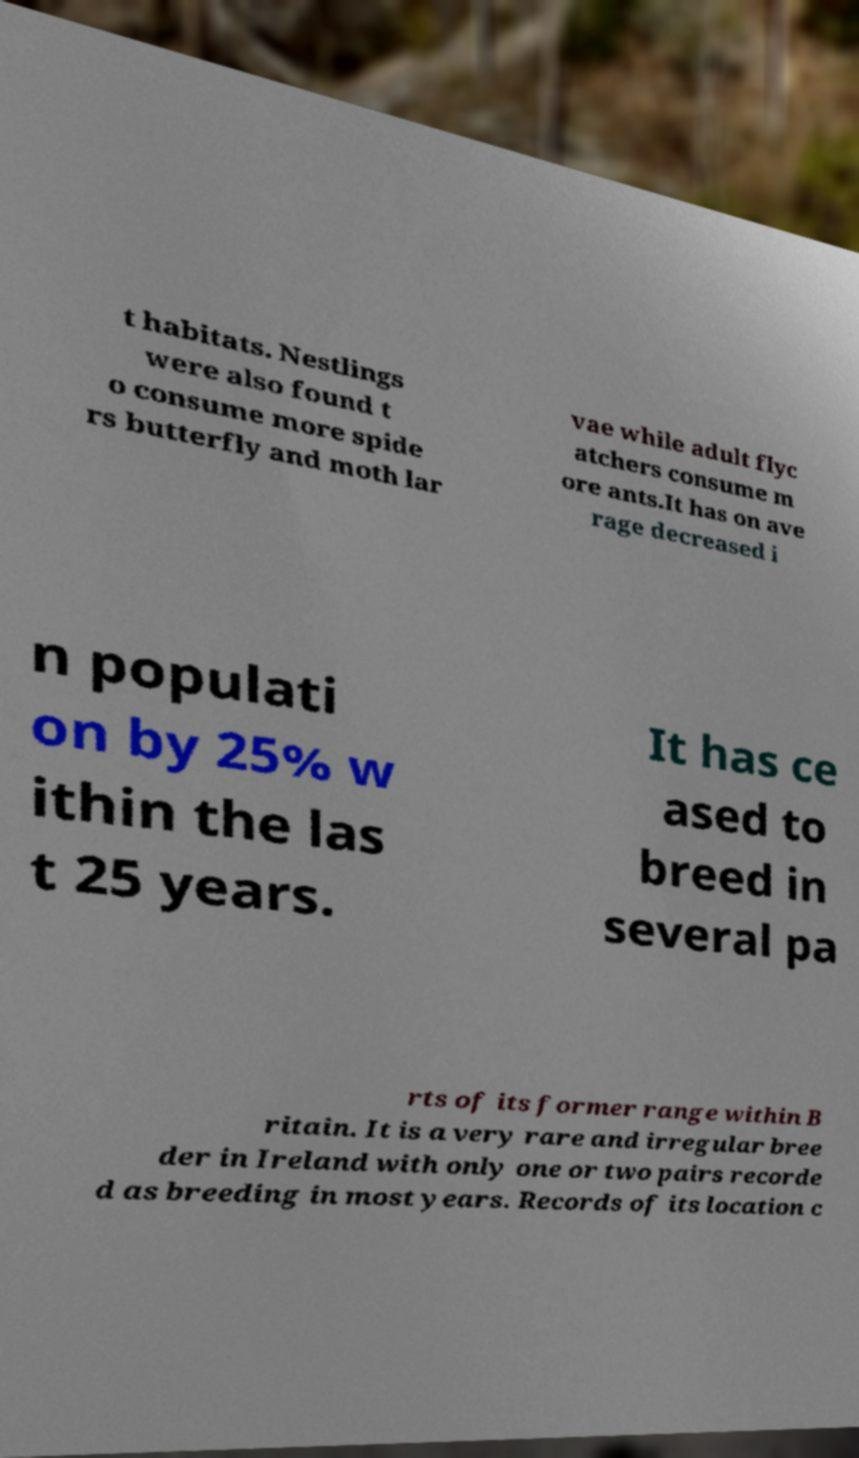Could you assist in decoding the text presented in this image and type it out clearly? t habitats. Nestlings were also found t o consume more spide rs butterfly and moth lar vae while adult flyc atchers consume m ore ants.It has on ave rage decreased i n populati on by 25% w ithin the las t 25 years. It has ce ased to breed in several pa rts of its former range within B ritain. It is a very rare and irregular bree der in Ireland with only one or two pairs recorde d as breeding in most years. Records of its location c 